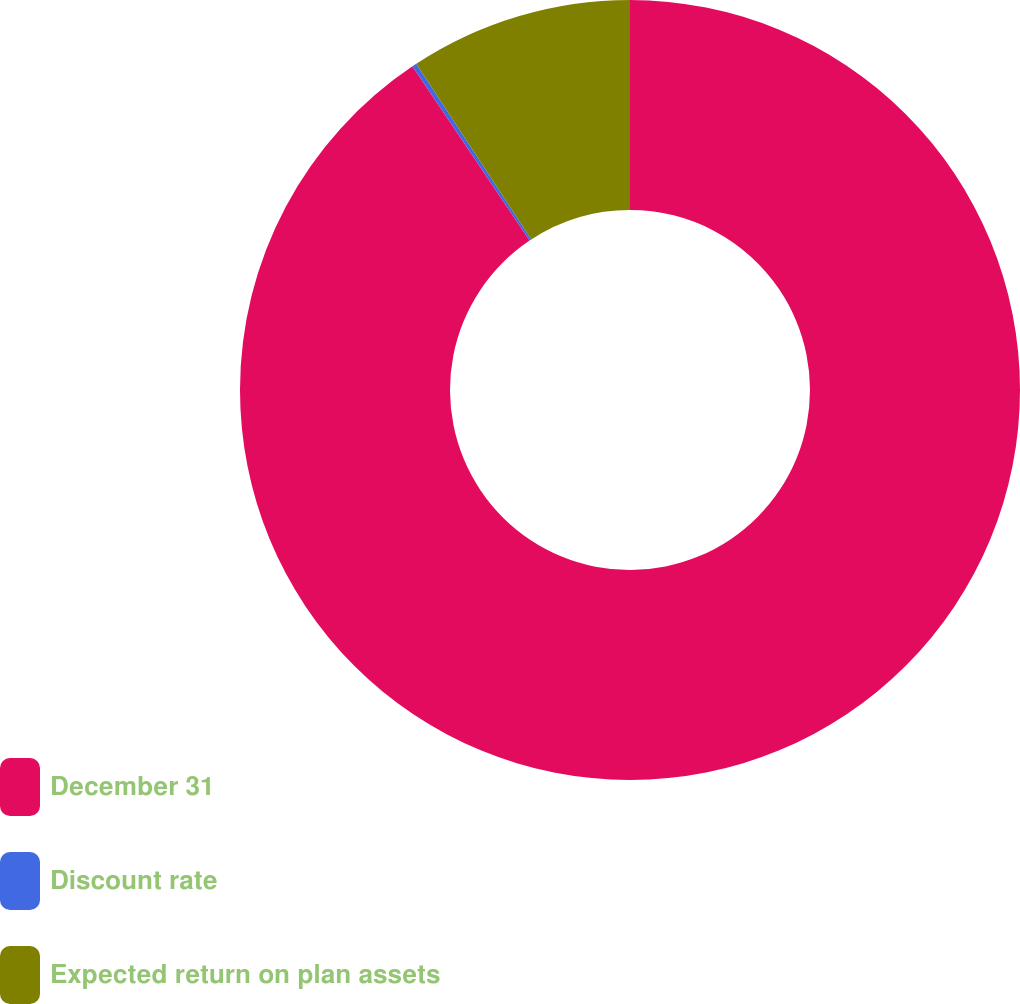<chart> <loc_0><loc_0><loc_500><loc_500><pie_chart><fcel>December 31<fcel>Discount rate<fcel>Expected return on plan assets<nl><fcel>90.59%<fcel>0.19%<fcel>9.23%<nl></chart> 